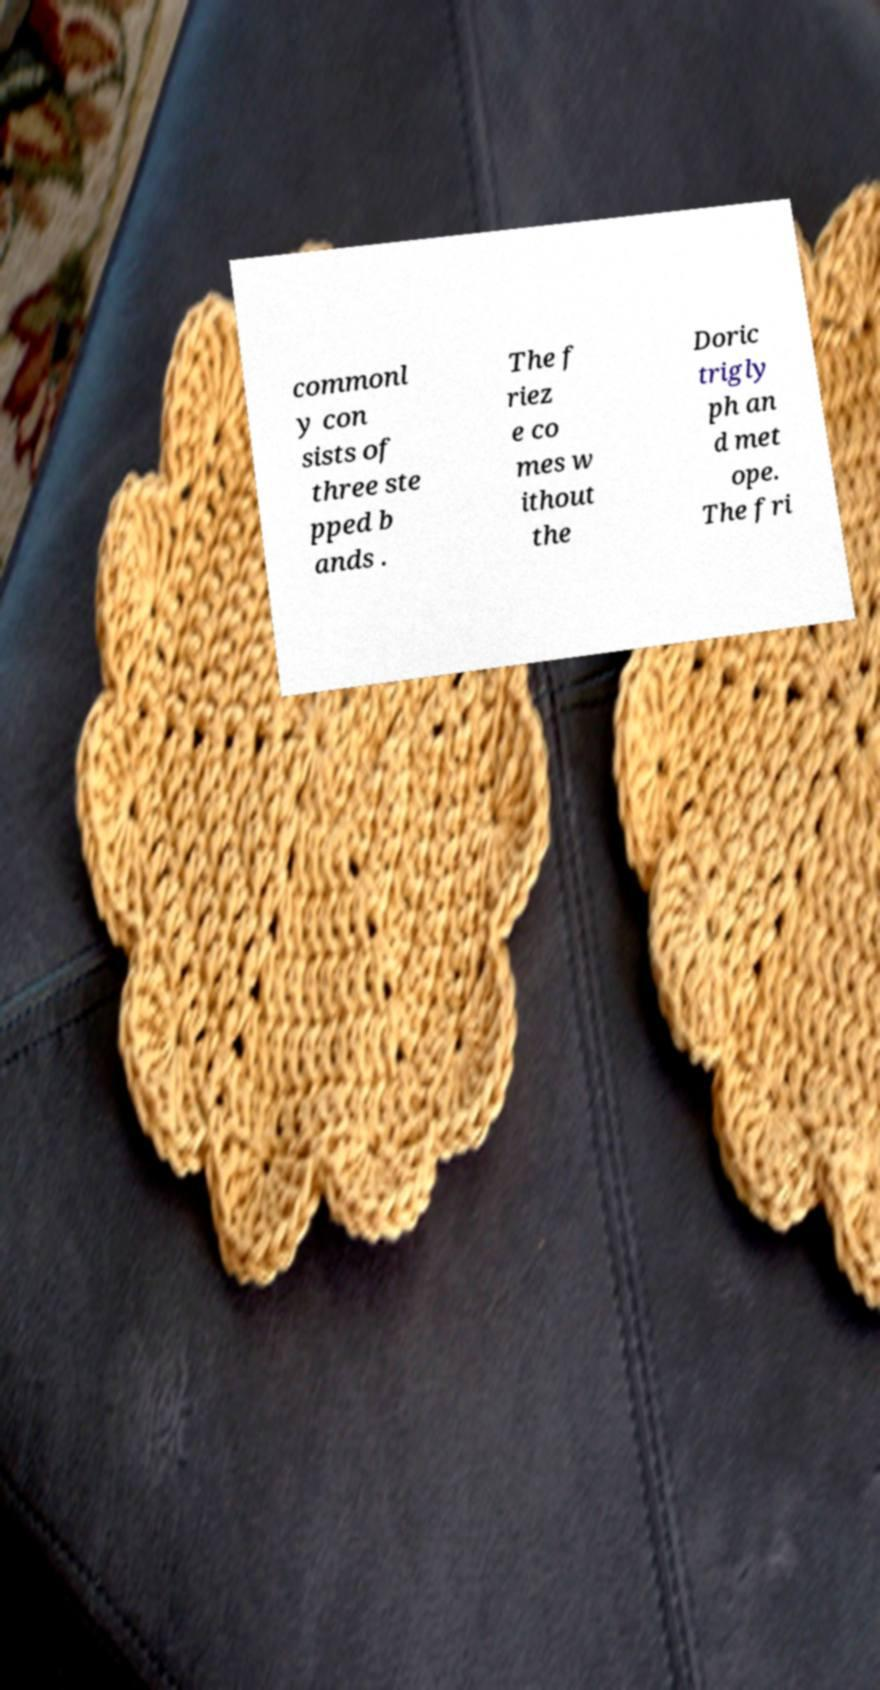Please identify and transcribe the text found in this image. commonl y con sists of three ste pped b ands . The f riez e co mes w ithout the Doric trigly ph an d met ope. The fri 